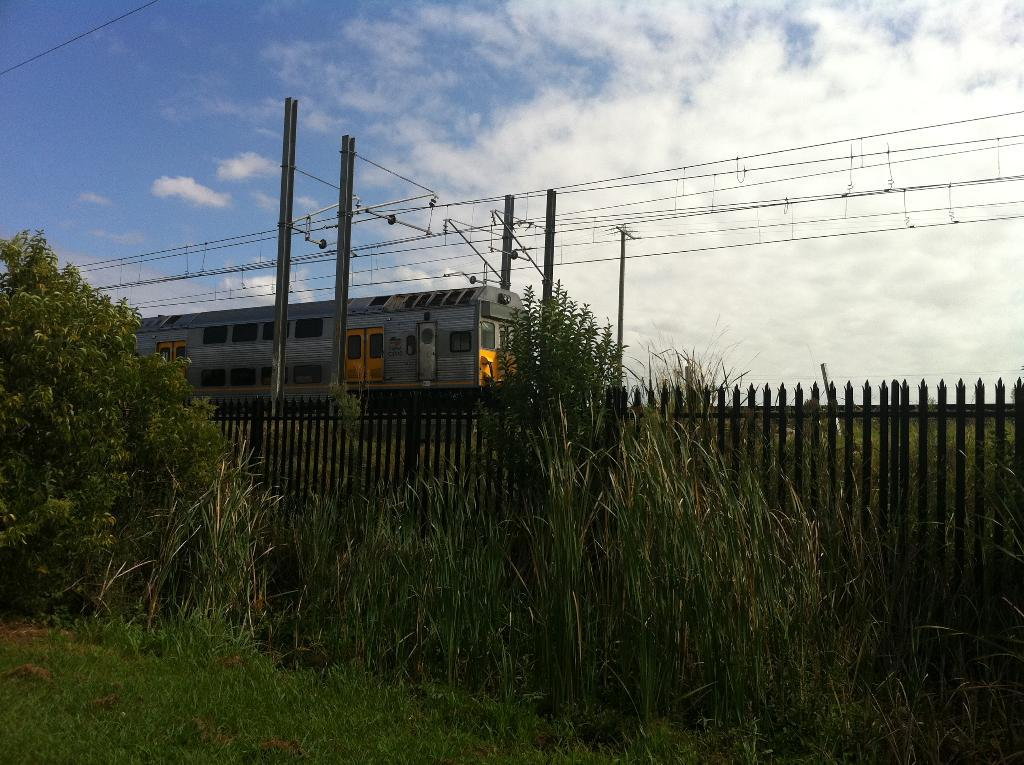What is the main subject in the center of the image? There is a train in the center of the image. What is the train positioned on? The train is on a track. What type of vegetation can be seen at the bottom of the image? There is grass at the bottom of the image. What structure is present at the bottom of the image? There is a fence at the bottom of the image. What else can be seen in the image besides the train? Trees, poles, wires, and the sky are visible in the image. Can you tell me how many kettles are hanging from the wires in the image? There are no kettles present in the image; only poles and wires can be seen. What type of cord is used to connect the train to the poles in the image? There is no cord connecting the train to the poles in the image; the train is on a track. 